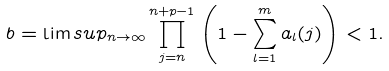Convert formula to latex. <formula><loc_0><loc_0><loc_500><loc_500>b = \lim s u p _ { n \to \infty } \prod _ { j = n } ^ { n + p - 1 } \left ( 1 - \sum _ { l = 1 } ^ { m } a _ { l } ( j ) \right ) < 1 .</formula> 